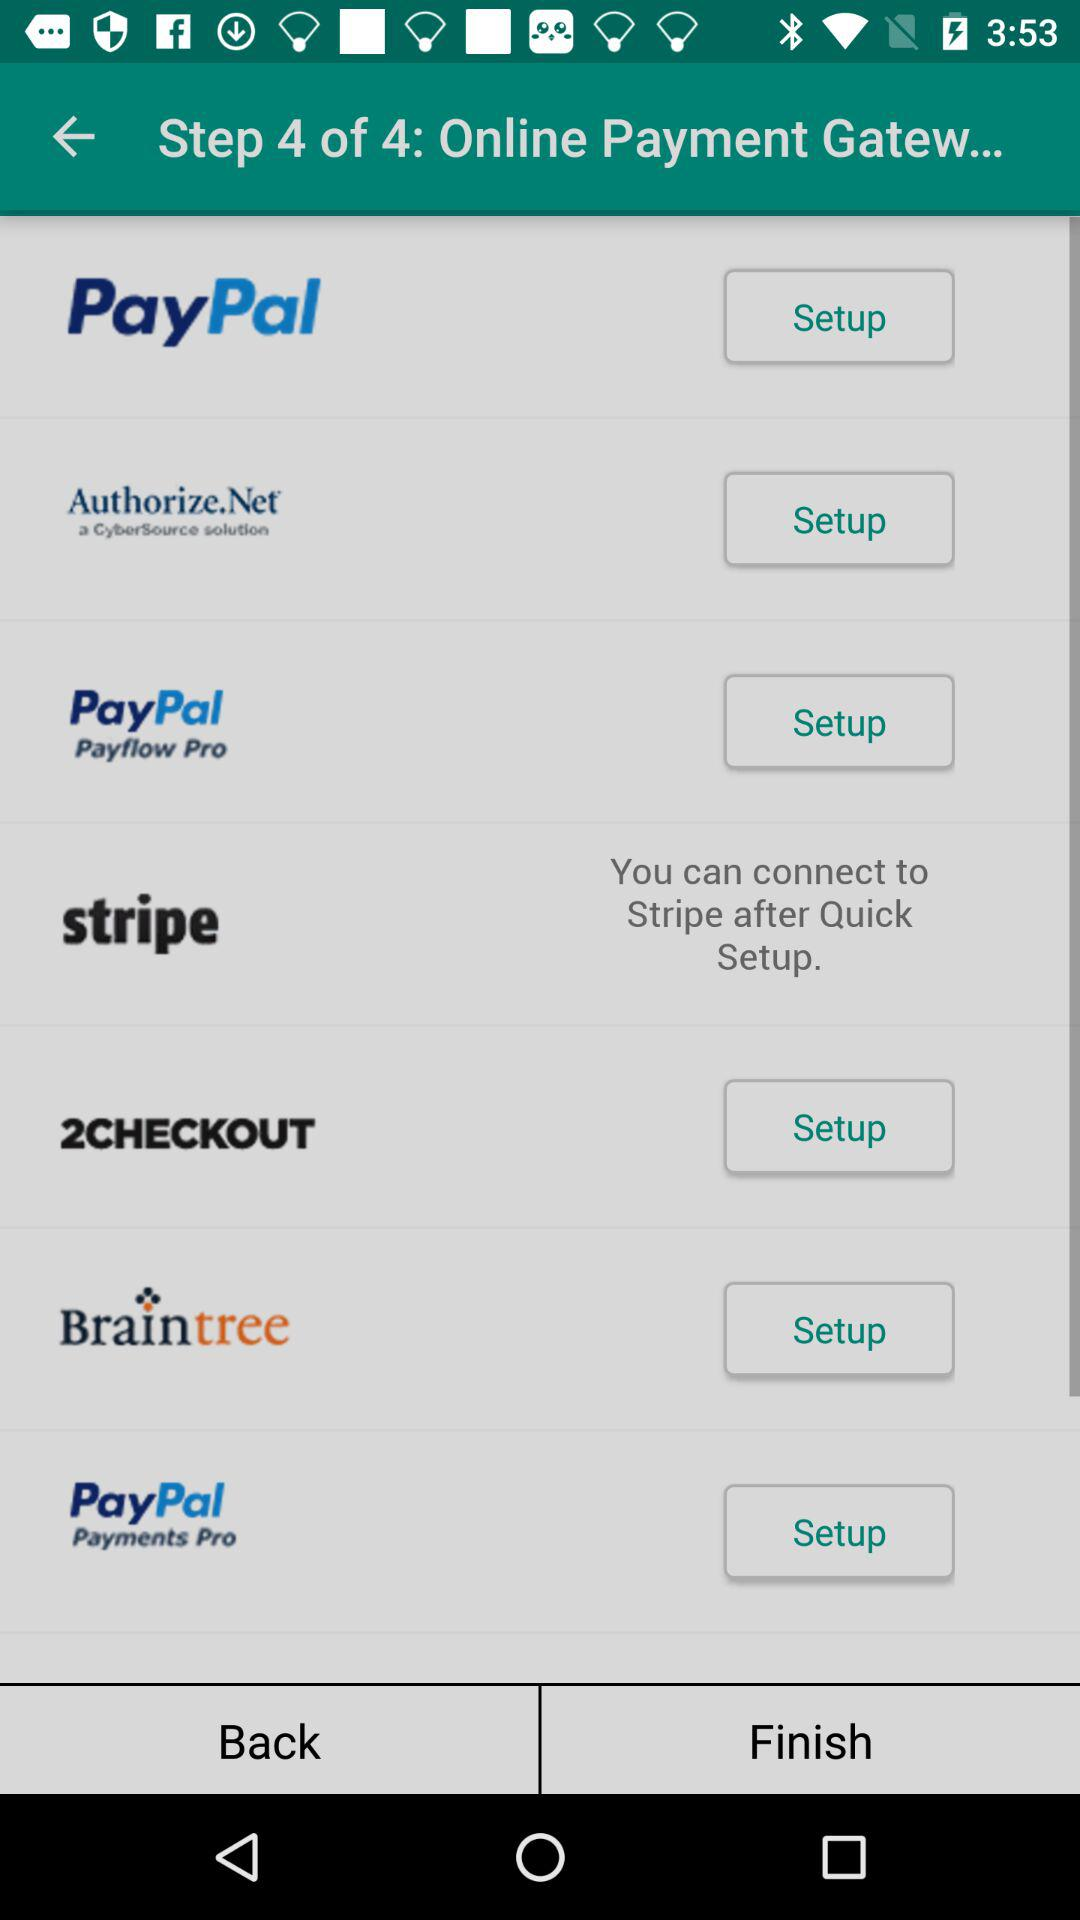On which step is the person? The person is on step 4. 